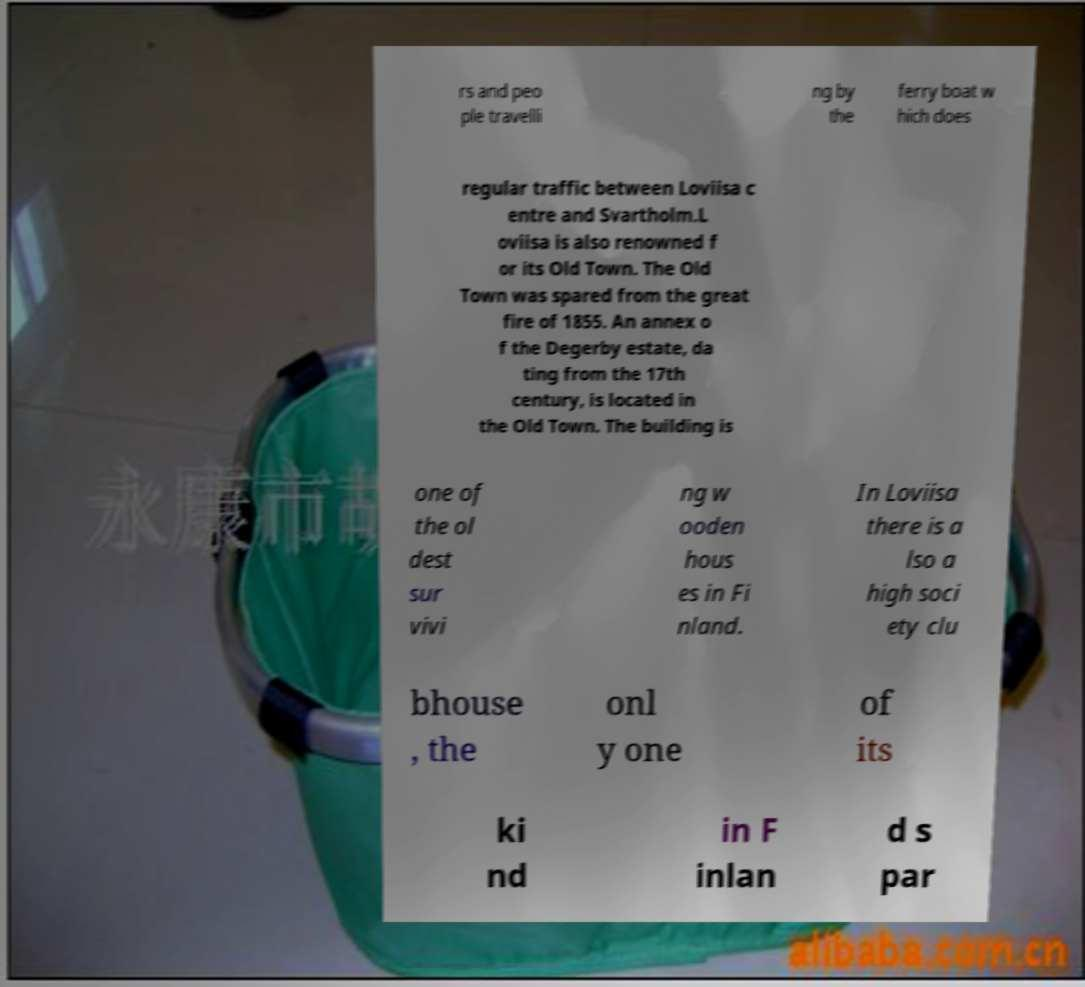For documentation purposes, I need the text within this image transcribed. Could you provide that? rs and peo ple travelli ng by the ferry boat w hich does regular traffic between Loviisa c entre and Svartholm.L oviisa is also renowned f or its Old Town. The Old Town was spared from the great fire of 1855. An annex o f the Degerby estate, da ting from the 17th century, is located in the Old Town. The building is one of the ol dest sur vivi ng w ooden hous es in Fi nland. In Loviisa there is a lso a high soci ety clu bhouse , the onl y one of its ki nd in F inlan d s par 